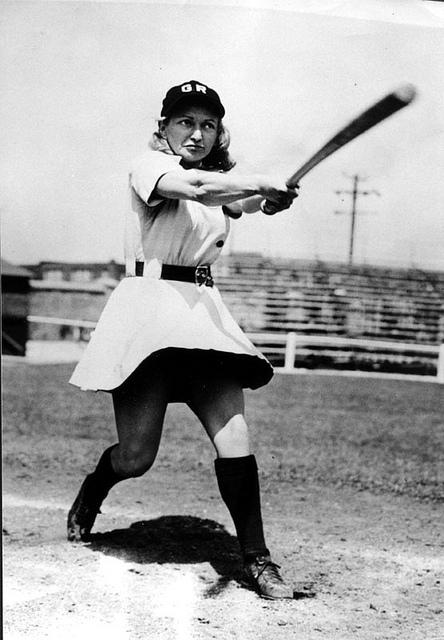What drink logo is on the scoreboard?
Keep it brief. None. Is the stadium full?
Be succinct. No. What is the girl doing?
Answer briefly. Baseball. What year is this baseball outfit?
Short answer required. 1950s. Did she hit a softball?
Give a very brief answer. Yes. 